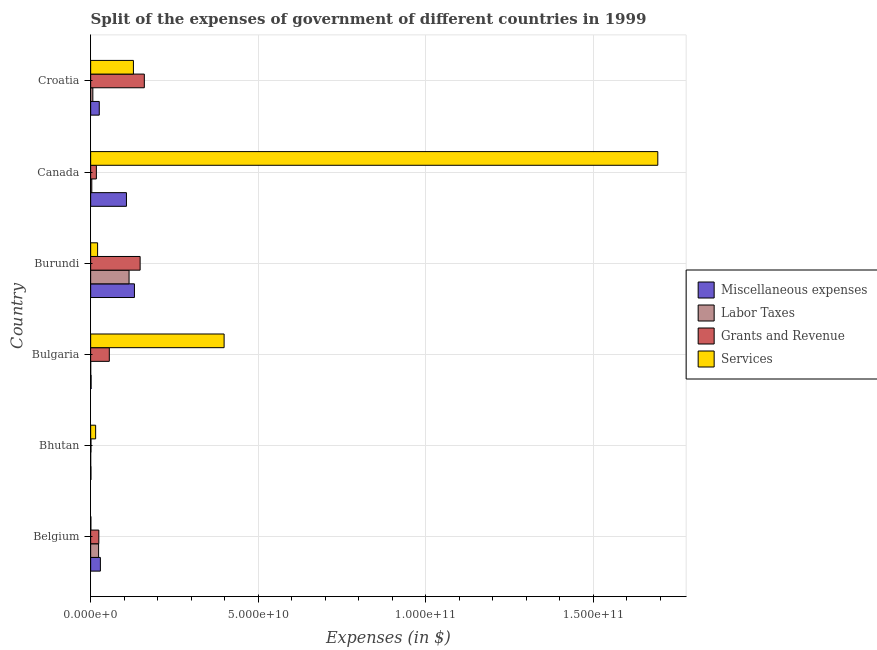How many different coloured bars are there?
Keep it short and to the point. 4. How many groups of bars are there?
Keep it short and to the point. 6. Are the number of bars on each tick of the Y-axis equal?
Offer a terse response. Yes. How many bars are there on the 5th tick from the top?
Your answer should be very brief. 4. What is the label of the 3rd group of bars from the top?
Keep it short and to the point. Burundi. What is the amount spent on services in Burundi?
Your answer should be compact. 2.07e+09. Across all countries, what is the maximum amount spent on services?
Your answer should be very brief. 1.69e+11. Across all countries, what is the minimum amount spent on grants and revenue?
Provide a succinct answer. 9.57e+07. In which country was the amount spent on grants and revenue minimum?
Offer a very short reply. Bhutan. What is the total amount spent on miscellaneous expenses in the graph?
Offer a very short reply. 2.94e+1. What is the difference between the amount spent on grants and revenue in Burundi and that in Canada?
Provide a succinct answer. 1.31e+1. What is the difference between the amount spent on labor taxes in Bulgaria and the amount spent on services in Belgium?
Ensure brevity in your answer.  -5.53e+07. What is the average amount spent on labor taxes per country?
Offer a terse response. 2.47e+09. What is the difference between the amount spent on grants and revenue and amount spent on services in Bulgaria?
Your answer should be compact. -3.42e+1. What is the ratio of the amount spent on services in Bulgaria to that in Canada?
Make the answer very short. 0.23. Is the difference between the amount spent on labor taxes in Bhutan and Canada greater than the difference between the amount spent on grants and revenue in Bhutan and Canada?
Your answer should be compact. Yes. What is the difference between the highest and the second highest amount spent on grants and revenue?
Your answer should be very brief. 1.25e+09. What is the difference between the highest and the lowest amount spent on services?
Offer a very short reply. 1.69e+11. What does the 1st bar from the top in Bulgaria represents?
Provide a succinct answer. Services. What does the 1st bar from the bottom in Bhutan represents?
Your answer should be compact. Miscellaneous expenses. How many bars are there?
Your answer should be compact. 24. What is the difference between two consecutive major ticks on the X-axis?
Your response must be concise. 5.00e+1. Are the values on the major ticks of X-axis written in scientific E-notation?
Ensure brevity in your answer.  Yes. Does the graph contain grids?
Keep it short and to the point. Yes. Where does the legend appear in the graph?
Provide a succinct answer. Center right. How are the legend labels stacked?
Provide a succinct answer. Vertical. What is the title of the graph?
Your answer should be very brief. Split of the expenses of government of different countries in 1999. What is the label or title of the X-axis?
Provide a succinct answer. Expenses (in $). What is the Expenses (in $) of Miscellaneous expenses in Belgium?
Give a very brief answer. 2.90e+09. What is the Expenses (in $) of Labor Taxes in Belgium?
Your answer should be very brief. 2.37e+09. What is the Expenses (in $) of Grants and Revenue in Belgium?
Keep it short and to the point. 2.44e+09. What is the Expenses (in $) of Services in Belgium?
Give a very brief answer. 6.24e+07. What is the Expenses (in $) in Miscellaneous expenses in Bhutan?
Keep it short and to the point. 8.63e+07. What is the Expenses (in $) in Labor Taxes in Bhutan?
Offer a terse response. 2.14e+06. What is the Expenses (in $) in Grants and Revenue in Bhutan?
Provide a succinct answer. 9.57e+07. What is the Expenses (in $) in Services in Bhutan?
Offer a very short reply. 1.49e+09. What is the Expenses (in $) of Miscellaneous expenses in Bulgaria?
Your answer should be compact. 1.36e+08. What is the Expenses (in $) of Labor Taxes in Bulgaria?
Give a very brief answer. 7.10e+06. What is the Expenses (in $) in Grants and Revenue in Bulgaria?
Offer a terse response. 5.57e+09. What is the Expenses (in $) in Services in Bulgaria?
Your answer should be compact. 3.98e+1. What is the Expenses (in $) of Miscellaneous expenses in Burundi?
Make the answer very short. 1.31e+1. What is the Expenses (in $) of Labor Taxes in Burundi?
Keep it short and to the point. 1.15e+1. What is the Expenses (in $) of Grants and Revenue in Burundi?
Offer a very short reply. 1.48e+1. What is the Expenses (in $) of Services in Burundi?
Keep it short and to the point. 2.07e+09. What is the Expenses (in $) in Miscellaneous expenses in Canada?
Your answer should be very brief. 1.07e+1. What is the Expenses (in $) in Labor Taxes in Canada?
Give a very brief answer. 3.39e+08. What is the Expenses (in $) of Grants and Revenue in Canada?
Keep it short and to the point. 1.70e+09. What is the Expenses (in $) of Services in Canada?
Offer a very short reply. 1.69e+11. What is the Expenses (in $) in Miscellaneous expenses in Croatia?
Offer a very short reply. 2.57e+09. What is the Expenses (in $) of Labor Taxes in Croatia?
Your answer should be compact. 6.53e+08. What is the Expenses (in $) in Grants and Revenue in Croatia?
Provide a succinct answer. 1.60e+1. What is the Expenses (in $) of Services in Croatia?
Your response must be concise. 1.28e+1. Across all countries, what is the maximum Expenses (in $) of Miscellaneous expenses?
Offer a terse response. 1.31e+1. Across all countries, what is the maximum Expenses (in $) of Labor Taxes?
Make the answer very short. 1.15e+1. Across all countries, what is the maximum Expenses (in $) of Grants and Revenue?
Provide a short and direct response. 1.60e+1. Across all countries, what is the maximum Expenses (in $) of Services?
Give a very brief answer. 1.69e+11. Across all countries, what is the minimum Expenses (in $) of Miscellaneous expenses?
Ensure brevity in your answer.  8.63e+07. Across all countries, what is the minimum Expenses (in $) of Labor Taxes?
Give a very brief answer. 2.14e+06. Across all countries, what is the minimum Expenses (in $) of Grants and Revenue?
Give a very brief answer. 9.57e+07. Across all countries, what is the minimum Expenses (in $) of Services?
Ensure brevity in your answer.  6.24e+07. What is the total Expenses (in $) in Miscellaneous expenses in the graph?
Give a very brief answer. 2.94e+1. What is the total Expenses (in $) in Labor Taxes in the graph?
Provide a short and direct response. 1.48e+1. What is the total Expenses (in $) of Grants and Revenue in the graph?
Keep it short and to the point. 4.06e+1. What is the total Expenses (in $) in Services in the graph?
Your response must be concise. 2.25e+11. What is the difference between the Expenses (in $) of Miscellaneous expenses in Belgium and that in Bhutan?
Give a very brief answer. 2.82e+09. What is the difference between the Expenses (in $) of Labor Taxes in Belgium and that in Bhutan?
Your response must be concise. 2.37e+09. What is the difference between the Expenses (in $) in Grants and Revenue in Belgium and that in Bhutan?
Provide a short and direct response. 2.34e+09. What is the difference between the Expenses (in $) in Services in Belgium and that in Bhutan?
Offer a terse response. -1.42e+09. What is the difference between the Expenses (in $) in Miscellaneous expenses in Belgium and that in Bulgaria?
Give a very brief answer. 2.77e+09. What is the difference between the Expenses (in $) of Labor Taxes in Belgium and that in Bulgaria?
Ensure brevity in your answer.  2.37e+09. What is the difference between the Expenses (in $) of Grants and Revenue in Belgium and that in Bulgaria?
Your answer should be very brief. -3.13e+09. What is the difference between the Expenses (in $) of Services in Belgium and that in Bulgaria?
Keep it short and to the point. -3.98e+1. What is the difference between the Expenses (in $) of Miscellaneous expenses in Belgium and that in Burundi?
Your response must be concise. -1.02e+1. What is the difference between the Expenses (in $) of Labor Taxes in Belgium and that in Burundi?
Provide a succinct answer. -9.09e+09. What is the difference between the Expenses (in $) in Grants and Revenue in Belgium and that in Burundi?
Keep it short and to the point. -1.23e+1. What is the difference between the Expenses (in $) in Services in Belgium and that in Burundi?
Your answer should be compact. -2.01e+09. What is the difference between the Expenses (in $) in Miscellaneous expenses in Belgium and that in Canada?
Provide a short and direct response. -7.78e+09. What is the difference between the Expenses (in $) of Labor Taxes in Belgium and that in Canada?
Keep it short and to the point. 2.03e+09. What is the difference between the Expenses (in $) in Grants and Revenue in Belgium and that in Canada?
Provide a short and direct response. 7.36e+08. What is the difference between the Expenses (in $) in Services in Belgium and that in Canada?
Keep it short and to the point. -1.69e+11. What is the difference between the Expenses (in $) of Miscellaneous expenses in Belgium and that in Croatia?
Offer a very short reply. 3.37e+08. What is the difference between the Expenses (in $) of Labor Taxes in Belgium and that in Croatia?
Provide a short and direct response. 1.72e+09. What is the difference between the Expenses (in $) in Grants and Revenue in Belgium and that in Croatia?
Your answer should be compact. -1.36e+1. What is the difference between the Expenses (in $) in Services in Belgium and that in Croatia?
Your answer should be compact. -1.27e+1. What is the difference between the Expenses (in $) in Miscellaneous expenses in Bhutan and that in Bulgaria?
Offer a terse response. -5.00e+07. What is the difference between the Expenses (in $) of Labor Taxes in Bhutan and that in Bulgaria?
Provide a succinct answer. -4.96e+06. What is the difference between the Expenses (in $) of Grants and Revenue in Bhutan and that in Bulgaria?
Provide a succinct answer. -5.47e+09. What is the difference between the Expenses (in $) in Services in Bhutan and that in Bulgaria?
Give a very brief answer. -3.83e+1. What is the difference between the Expenses (in $) in Miscellaneous expenses in Bhutan and that in Burundi?
Give a very brief answer. -1.30e+1. What is the difference between the Expenses (in $) in Labor Taxes in Bhutan and that in Burundi?
Ensure brevity in your answer.  -1.15e+1. What is the difference between the Expenses (in $) in Grants and Revenue in Bhutan and that in Burundi?
Ensure brevity in your answer.  -1.47e+1. What is the difference between the Expenses (in $) of Services in Bhutan and that in Burundi?
Your answer should be very brief. -5.82e+08. What is the difference between the Expenses (in $) in Miscellaneous expenses in Bhutan and that in Canada?
Make the answer very short. -1.06e+1. What is the difference between the Expenses (in $) of Labor Taxes in Bhutan and that in Canada?
Offer a very short reply. -3.37e+08. What is the difference between the Expenses (in $) in Grants and Revenue in Bhutan and that in Canada?
Your answer should be very brief. -1.61e+09. What is the difference between the Expenses (in $) in Services in Bhutan and that in Canada?
Ensure brevity in your answer.  -1.68e+11. What is the difference between the Expenses (in $) of Miscellaneous expenses in Bhutan and that in Croatia?
Provide a short and direct response. -2.48e+09. What is the difference between the Expenses (in $) in Labor Taxes in Bhutan and that in Croatia?
Give a very brief answer. -6.51e+08. What is the difference between the Expenses (in $) of Grants and Revenue in Bhutan and that in Croatia?
Your answer should be very brief. -1.59e+1. What is the difference between the Expenses (in $) in Services in Bhutan and that in Croatia?
Your answer should be compact. -1.13e+1. What is the difference between the Expenses (in $) of Miscellaneous expenses in Bulgaria and that in Burundi?
Offer a very short reply. -1.29e+1. What is the difference between the Expenses (in $) of Labor Taxes in Bulgaria and that in Burundi?
Your response must be concise. -1.15e+1. What is the difference between the Expenses (in $) in Grants and Revenue in Bulgaria and that in Burundi?
Provide a succinct answer. -9.19e+09. What is the difference between the Expenses (in $) in Services in Bulgaria and that in Burundi?
Ensure brevity in your answer.  3.77e+1. What is the difference between the Expenses (in $) of Miscellaneous expenses in Bulgaria and that in Canada?
Offer a terse response. -1.05e+1. What is the difference between the Expenses (in $) of Labor Taxes in Bulgaria and that in Canada?
Your response must be concise. -3.32e+08. What is the difference between the Expenses (in $) in Grants and Revenue in Bulgaria and that in Canada?
Offer a terse response. 3.86e+09. What is the difference between the Expenses (in $) in Services in Bulgaria and that in Canada?
Your answer should be compact. -1.29e+11. What is the difference between the Expenses (in $) of Miscellaneous expenses in Bulgaria and that in Croatia?
Your answer should be very brief. -2.43e+09. What is the difference between the Expenses (in $) of Labor Taxes in Bulgaria and that in Croatia?
Your answer should be very brief. -6.46e+08. What is the difference between the Expenses (in $) of Grants and Revenue in Bulgaria and that in Croatia?
Ensure brevity in your answer.  -1.04e+1. What is the difference between the Expenses (in $) of Services in Bulgaria and that in Croatia?
Offer a very short reply. 2.71e+1. What is the difference between the Expenses (in $) in Miscellaneous expenses in Burundi and that in Canada?
Your response must be concise. 2.38e+09. What is the difference between the Expenses (in $) in Labor Taxes in Burundi and that in Canada?
Make the answer very short. 1.11e+1. What is the difference between the Expenses (in $) in Grants and Revenue in Burundi and that in Canada?
Keep it short and to the point. 1.31e+1. What is the difference between the Expenses (in $) of Services in Burundi and that in Canada?
Make the answer very short. -1.67e+11. What is the difference between the Expenses (in $) of Miscellaneous expenses in Burundi and that in Croatia?
Ensure brevity in your answer.  1.05e+1. What is the difference between the Expenses (in $) of Labor Taxes in Burundi and that in Croatia?
Your response must be concise. 1.08e+1. What is the difference between the Expenses (in $) of Grants and Revenue in Burundi and that in Croatia?
Your answer should be compact. -1.25e+09. What is the difference between the Expenses (in $) of Services in Burundi and that in Croatia?
Provide a succinct answer. -1.07e+1. What is the difference between the Expenses (in $) of Miscellaneous expenses in Canada and that in Croatia?
Keep it short and to the point. 8.11e+09. What is the difference between the Expenses (in $) in Labor Taxes in Canada and that in Croatia?
Your answer should be compact. -3.14e+08. What is the difference between the Expenses (in $) of Grants and Revenue in Canada and that in Croatia?
Provide a short and direct response. -1.43e+1. What is the difference between the Expenses (in $) of Services in Canada and that in Croatia?
Offer a terse response. 1.56e+11. What is the difference between the Expenses (in $) in Miscellaneous expenses in Belgium and the Expenses (in $) in Labor Taxes in Bhutan?
Offer a very short reply. 2.90e+09. What is the difference between the Expenses (in $) of Miscellaneous expenses in Belgium and the Expenses (in $) of Grants and Revenue in Bhutan?
Ensure brevity in your answer.  2.81e+09. What is the difference between the Expenses (in $) of Miscellaneous expenses in Belgium and the Expenses (in $) of Services in Bhutan?
Keep it short and to the point. 1.42e+09. What is the difference between the Expenses (in $) of Labor Taxes in Belgium and the Expenses (in $) of Grants and Revenue in Bhutan?
Provide a short and direct response. 2.28e+09. What is the difference between the Expenses (in $) in Labor Taxes in Belgium and the Expenses (in $) in Services in Bhutan?
Make the answer very short. 8.86e+08. What is the difference between the Expenses (in $) in Grants and Revenue in Belgium and the Expenses (in $) in Services in Bhutan?
Keep it short and to the point. 9.54e+08. What is the difference between the Expenses (in $) in Miscellaneous expenses in Belgium and the Expenses (in $) in Labor Taxes in Bulgaria?
Provide a succinct answer. 2.90e+09. What is the difference between the Expenses (in $) of Miscellaneous expenses in Belgium and the Expenses (in $) of Grants and Revenue in Bulgaria?
Make the answer very short. -2.66e+09. What is the difference between the Expenses (in $) of Miscellaneous expenses in Belgium and the Expenses (in $) of Services in Bulgaria?
Give a very brief answer. -3.69e+1. What is the difference between the Expenses (in $) in Labor Taxes in Belgium and the Expenses (in $) in Grants and Revenue in Bulgaria?
Your answer should be compact. -3.19e+09. What is the difference between the Expenses (in $) in Labor Taxes in Belgium and the Expenses (in $) in Services in Bulgaria?
Give a very brief answer. -3.74e+1. What is the difference between the Expenses (in $) in Grants and Revenue in Belgium and the Expenses (in $) in Services in Bulgaria?
Your answer should be very brief. -3.74e+1. What is the difference between the Expenses (in $) of Miscellaneous expenses in Belgium and the Expenses (in $) of Labor Taxes in Burundi?
Ensure brevity in your answer.  -8.55e+09. What is the difference between the Expenses (in $) of Miscellaneous expenses in Belgium and the Expenses (in $) of Grants and Revenue in Burundi?
Provide a short and direct response. -1.19e+1. What is the difference between the Expenses (in $) of Miscellaneous expenses in Belgium and the Expenses (in $) of Services in Burundi?
Ensure brevity in your answer.  8.36e+08. What is the difference between the Expenses (in $) in Labor Taxes in Belgium and the Expenses (in $) in Grants and Revenue in Burundi?
Make the answer very short. -1.24e+1. What is the difference between the Expenses (in $) of Labor Taxes in Belgium and the Expenses (in $) of Services in Burundi?
Your answer should be compact. 3.05e+08. What is the difference between the Expenses (in $) of Grants and Revenue in Belgium and the Expenses (in $) of Services in Burundi?
Offer a terse response. 3.72e+08. What is the difference between the Expenses (in $) of Miscellaneous expenses in Belgium and the Expenses (in $) of Labor Taxes in Canada?
Give a very brief answer. 2.56e+09. What is the difference between the Expenses (in $) of Miscellaneous expenses in Belgium and the Expenses (in $) of Grants and Revenue in Canada?
Provide a short and direct response. 1.20e+09. What is the difference between the Expenses (in $) of Miscellaneous expenses in Belgium and the Expenses (in $) of Services in Canada?
Ensure brevity in your answer.  -1.66e+11. What is the difference between the Expenses (in $) of Labor Taxes in Belgium and the Expenses (in $) of Grants and Revenue in Canada?
Keep it short and to the point. 6.69e+08. What is the difference between the Expenses (in $) of Labor Taxes in Belgium and the Expenses (in $) of Services in Canada?
Offer a terse response. -1.67e+11. What is the difference between the Expenses (in $) of Grants and Revenue in Belgium and the Expenses (in $) of Services in Canada?
Offer a very short reply. -1.67e+11. What is the difference between the Expenses (in $) of Miscellaneous expenses in Belgium and the Expenses (in $) of Labor Taxes in Croatia?
Keep it short and to the point. 2.25e+09. What is the difference between the Expenses (in $) in Miscellaneous expenses in Belgium and the Expenses (in $) in Grants and Revenue in Croatia?
Your response must be concise. -1.31e+1. What is the difference between the Expenses (in $) in Miscellaneous expenses in Belgium and the Expenses (in $) in Services in Croatia?
Your answer should be very brief. -9.85e+09. What is the difference between the Expenses (in $) in Labor Taxes in Belgium and the Expenses (in $) in Grants and Revenue in Croatia?
Provide a short and direct response. -1.36e+1. What is the difference between the Expenses (in $) of Labor Taxes in Belgium and the Expenses (in $) of Services in Croatia?
Make the answer very short. -1.04e+1. What is the difference between the Expenses (in $) in Grants and Revenue in Belgium and the Expenses (in $) in Services in Croatia?
Give a very brief answer. -1.03e+1. What is the difference between the Expenses (in $) of Miscellaneous expenses in Bhutan and the Expenses (in $) of Labor Taxes in Bulgaria?
Keep it short and to the point. 7.92e+07. What is the difference between the Expenses (in $) in Miscellaneous expenses in Bhutan and the Expenses (in $) in Grants and Revenue in Bulgaria?
Provide a short and direct response. -5.48e+09. What is the difference between the Expenses (in $) of Miscellaneous expenses in Bhutan and the Expenses (in $) of Services in Bulgaria?
Ensure brevity in your answer.  -3.97e+1. What is the difference between the Expenses (in $) in Labor Taxes in Bhutan and the Expenses (in $) in Grants and Revenue in Bulgaria?
Keep it short and to the point. -5.57e+09. What is the difference between the Expenses (in $) of Labor Taxes in Bhutan and the Expenses (in $) of Services in Bulgaria?
Provide a short and direct response. -3.98e+1. What is the difference between the Expenses (in $) of Grants and Revenue in Bhutan and the Expenses (in $) of Services in Bulgaria?
Offer a terse response. -3.97e+1. What is the difference between the Expenses (in $) of Miscellaneous expenses in Bhutan and the Expenses (in $) of Labor Taxes in Burundi?
Offer a very short reply. -1.14e+1. What is the difference between the Expenses (in $) in Miscellaneous expenses in Bhutan and the Expenses (in $) in Grants and Revenue in Burundi?
Provide a succinct answer. -1.47e+1. What is the difference between the Expenses (in $) in Miscellaneous expenses in Bhutan and the Expenses (in $) in Services in Burundi?
Provide a succinct answer. -1.98e+09. What is the difference between the Expenses (in $) of Labor Taxes in Bhutan and the Expenses (in $) of Grants and Revenue in Burundi?
Your response must be concise. -1.48e+1. What is the difference between the Expenses (in $) in Labor Taxes in Bhutan and the Expenses (in $) in Services in Burundi?
Your response must be concise. -2.07e+09. What is the difference between the Expenses (in $) of Grants and Revenue in Bhutan and the Expenses (in $) of Services in Burundi?
Your response must be concise. -1.97e+09. What is the difference between the Expenses (in $) in Miscellaneous expenses in Bhutan and the Expenses (in $) in Labor Taxes in Canada?
Provide a short and direct response. -2.53e+08. What is the difference between the Expenses (in $) in Miscellaneous expenses in Bhutan and the Expenses (in $) in Grants and Revenue in Canada?
Your answer should be compact. -1.62e+09. What is the difference between the Expenses (in $) of Miscellaneous expenses in Bhutan and the Expenses (in $) of Services in Canada?
Offer a very short reply. -1.69e+11. What is the difference between the Expenses (in $) in Labor Taxes in Bhutan and the Expenses (in $) in Grants and Revenue in Canada?
Offer a very short reply. -1.70e+09. What is the difference between the Expenses (in $) in Labor Taxes in Bhutan and the Expenses (in $) in Services in Canada?
Offer a terse response. -1.69e+11. What is the difference between the Expenses (in $) in Grants and Revenue in Bhutan and the Expenses (in $) in Services in Canada?
Provide a succinct answer. -1.69e+11. What is the difference between the Expenses (in $) of Miscellaneous expenses in Bhutan and the Expenses (in $) of Labor Taxes in Croatia?
Provide a short and direct response. -5.67e+08. What is the difference between the Expenses (in $) of Miscellaneous expenses in Bhutan and the Expenses (in $) of Grants and Revenue in Croatia?
Keep it short and to the point. -1.59e+1. What is the difference between the Expenses (in $) of Miscellaneous expenses in Bhutan and the Expenses (in $) of Services in Croatia?
Keep it short and to the point. -1.27e+1. What is the difference between the Expenses (in $) of Labor Taxes in Bhutan and the Expenses (in $) of Grants and Revenue in Croatia?
Your answer should be very brief. -1.60e+1. What is the difference between the Expenses (in $) of Labor Taxes in Bhutan and the Expenses (in $) of Services in Croatia?
Offer a terse response. -1.28e+1. What is the difference between the Expenses (in $) in Grants and Revenue in Bhutan and the Expenses (in $) in Services in Croatia?
Provide a succinct answer. -1.27e+1. What is the difference between the Expenses (in $) in Miscellaneous expenses in Bulgaria and the Expenses (in $) in Labor Taxes in Burundi?
Provide a succinct answer. -1.13e+1. What is the difference between the Expenses (in $) in Miscellaneous expenses in Bulgaria and the Expenses (in $) in Grants and Revenue in Burundi?
Provide a short and direct response. -1.46e+1. What is the difference between the Expenses (in $) of Miscellaneous expenses in Bulgaria and the Expenses (in $) of Services in Burundi?
Your response must be concise. -1.93e+09. What is the difference between the Expenses (in $) in Labor Taxes in Bulgaria and the Expenses (in $) in Grants and Revenue in Burundi?
Provide a succinct answer. -1.48e+1. What is the difference between the Expenses (in $) of Labor Taxes in Bulgaria and the Expenses (in $) of Services in Burundi?
Make the answer very short. -2.06e+09. What is the difference between the Expenses (in $) in Grants and Revenue in Bulgaria and the Expenses (in $) in Services in Burundi?
Offer a very short reply. 3.50e+09. What is the difference between the Expenses (in $) of Miscellaneous expenses in Bulgaria and the Expenses (in $) of Labor Taxes in Canada?
Give a very brief answer. -2.03e+08. What is the difference between the Expenses (in $) in Miscellaneous expenses in Bulgaria and the Expenses (in $) in Grants and Revenue in Canada?
Make the answer very short. -1.57e+09. What is the difference between the Expenses (in $) of Miscellaneous expenses in Bulgaria and the Expenses (in $) of Services in Canada?
Provide a succinct answer. -1.69e+11. What is the difference between the Expenses (in $) of Labor Taxes in Bulgaria and the Expenses (in $) of Grants and Revenue in Canada?
Give a very brief answer. -1.70e+09. What is the difference between the Expenses (in $) in Labor Taxes in Bulgaria and the Expenses (in $) in Services in Canada?
Give a very brief answer. -1.69e+11. What is the difference between the Expenses (in $) of Grants and Revenue in Bulgaria and the Expenses (in $) of Services in Canada?
Give a very brief answer. -1.64e+11. What is the difference between the Expenses (in $) of Miscellaneous expenses in Bulgaria and the Expenses (in $) of Labor Taxes in Croatia?
Offer a terse response. -5.17e+08. What is the difference between the Expenses (in $) in Miscellaneous expenses in Bulgaria and the Expenses (in $) in Grants and Revenue in Croatia?
Provide a succinct answer. -1.59e+1. What is the difference between the Expenses (in $) in Miscellaneous expenses in Bulgaria and the Expenses (in $) in Services in Croatia?
Give a very brief answer. -1.26e+1. What is the difference between the Expenses (in $) of Labor Taxes in Bulgaria and the Expenses (in $) of Grants and Revenue in Croatia?
Make the answer very short. -1.60e+1. What is the difference between the Expenses (in $) in Labor Taxes in Bulgaria and the Expenses (in $) in Services in Croatia?
Your answer should be compact. -1.27e+1. What is the difference between the Expenses (in $) in Grants and Revenue in Bulgaria and the Expenses (in $) in Services in Croatia?
Make the answer very short. -7.19e+09. What is the difference between the Expenses (in $) in Miscellaneous expenses in Burundi and the Expenses (in $) in Labor Taxes in Canada?
Your answer should be very brief. 1.27e+1. What is the difference between the Expenses (in $) in Miscellaneous expenses in Burundi and the Expenses (in $) in Grants and Revenue in Canada?
Keep it short and to the point. 1.14e+1. What is the difference between the Expenses (in $) in Miscellaneous expenses in Burundi and the Expenses (in $) in Services in Canada?
Your answer should be compact. -1.56e+11. What is the difference between the Expenses (in $) of Labor Taxes in Burundi and the Expenses (in $) of Grants and Revenue in Canada?
Make the answer very short. 9.75e+09. What is the difference between the Expenses (in $) in Labor Taxes in Burundi and the Expenses (in $) in Services in Canada?
Provide a short and direct response. -1.58e+11. What is the difference between the Expenses (in $) of Grants and Revenue in Burundi and the Expenses (in $) of Services in Canada?
Ensure brevity in your answer.  -1.54e+11. What is the difference between the Expenses (in $) in Miscellaneous expenses in Burundi and the Expenses (in $) in Labor Taxes in Croatia?
Give a very brief answer. 1.24e+1. What is the difference between the Expenses (in $) of Miscellaneous expenses in Burundi and the Expenses (in $) of Grants and Revenue in Croatia?
Make the answer very short. -2.95e+09. What is the difference between the Expenses (in $) in Miscellaneous expenses in Burundi and the Expenses (in $) in Services in Croatia?
Offer a terse response. 3.07e+08. What is the difference between the Expenses (in $) in Labor Taxes in Burundi and the Expenses (in $) in Grants and Revenue in Croatia?
Ensure brevity in your answer.  -4.55e+09. What is the difference between the Expenses (in $) of Labor Taxes in Burundi and the Expenses (in $) of Services in Croatia?
Keep it short and to the point. -1.30e+09. What is the difference between the Expenses (in $) of Grants and Revenue in Burundi and the Expenses (in $) of Services in Croatia?
Make the answer very short. 2.00e+09. What is the difference between the Expenses (in $) of Miscellaneous expenses in Canada and the Expenses (in $) of Labor Taxes in Croatia?
Offer a very short reply. 1.00e+1. What is the difference between the Expenses (in $) in Miscellaneous expenses in Canada and the Expenses (in $) in Grants and Revenue in Croatia?
Keep it short and to the point. -5.33e+09. What is the difference between the Expenses (in $) of Miscellaneous expenses in Canada and the Expenses (in $) of Services in Croatia?
Give a very brief answer. -2.08e+09. What is the difference between the Expenses (in $) in Labor Taxes in Canada and the Expenses (in $) in Grants and Revenue in Croatia?
Offer a very short reply. -1.57e+1. What is the difference between the Expenses (in $) of Labor Taxes in Canada and the Expenses (in $) of Services in Croatia?
Your answer should be very brief. -1.24e+1. What is the difference between the Expenses (in $) in Grants and Revenue in Canada and the Expenses (in $) in Services in Croatia?
Your response must be concise. -1.11e+1. What is the average Expenses (in $) in Miscellaneous expenses per country?
Your answer should be compact. 4.91e+09. What is the average Expenses (in $) in Labor Taxes per country?
Make the answer very short. 2.47e+09. What is the average Expenses (in $) of Grants and Revenue per country?
Keep it short and to the point. 6.76e+09. What is the average Expenses (in $) of Services per country?
Your response must be concise. 3.76e+1. What is the difference between the Expenses (in $) of Miscellaneous expenses and Expenses (in $) of Labor Taxes in Belgium?
Keep it short and to the point. 5.31e+08. What is the difference between the Expenses (in $) in Miscellaneous expenses and Expenses (in $) in Grants and Revenue in Belgium?
Offer a very short reply. 4.64e+08. What is the difference between the Expenses (in $) in Miscellaneous expenses and Expenses (in $) in Services in Belgium?
Give a very brief answer. 2.84e+09. What is the difference between the Expenses (in $) of Labor Taxes and Expenses (in $) of Grants and Revenue in Belgium?
Keep it short and to the point. -6.70e+07. What is the difference between the Expenses (in $) of Labor Taxes and Expenses (in $) of Services in Belgium?
Make the answer very short. 2.31e+09. What is the difference between the Expenses (in $) of Grants and Revenue and Expenses (in $) of Services in Belgium?
Your response must be concise. 2.38e+09. What is the difference between the Expenses (in $) of Miscellaneous expenses and Expenses (in $) of Labor Taxes in Bhutan?
Your response must be concise. 8.42e+07. What is the difference between the Expenses (in $) of Miscellaneous expenses and Expenses (in $) of Grants and Revenue in Bhutan?
Your response must be concise. -9.38e+06. What is the difference between the Expenses (in $) in Miscellaneous expenses and Expenses (in $) in Services in Bhutan?
Provide a succinct answer. -1.40e+09. What is the difference between the Expenses (in $) in Labor Taxes and Expenses (in $) in Grants and Revenue in Bhutan?
Provide a succinct answer. -9.35e+07. What is the difference between the Expenses (in $) in Labor Taxes and Expenses (in $) in Services in Bhutan?
Offer a very short reply. -1.48e+09. What is the difference between the Expenses (in $) in Grants and Revenue and Expenses (in $) in Services in Bhutan?
Ensure brevity in your answer.  -1.39e+09. What is the difference between the Expenses (in $) in Miscellaneous expenses and Expenses (in $) in Labor Taxes in Bulgaria?
Ensure brevity in your answer.  1.29e+08. What is the difference between the Expenses (in $) of Miscellaneous expenses and Expenses (in $) of Grants and Revenue in Bulgaria?
Offer a very short reply. -5.43e+09. What is the difference between the Expenses (in $) in Miscellaneous expenses and Expenses (in $) in Services in Bulgaria?
Provide a succinct answer. -3.97e+1. What is the difference between the Expenses (in $) of Labor Taxes and Expenses (in $) of Grants and Revenue in Bulgaria?
Your answer should be compact. -5.56e+09. What is the difference between the Expenses (in $) in Labor Taxes and Expenses (in $) in Services in Bulgaria?
Your response must be concise. -3.98e+1. What is the difference between the Expenses (in $) of Grants and Revenue and Expenses (in $) of Services in Bulgaria?
Offer a very short reply. -3.42e+1. What is the difference between the Expenses (in $) of Miscellaneous expenses and Expenses (in $) of Labor Taxes in Burundi?
Your answer should be compact. 1.60e+09. What is the difference between the Expenses (in $) in Miscellaneous expenses and Expenses (in $) in Grants and Revenue in Burundi?
Provide a succinct answer. -1.70e+09. What is the difference between the Expenses (in $) of Miscellaneous expenses and Expenses (in $) of Services in Burundi?
Give a very brief answer. 1.10e+1. What is the difference between the Expenses (in $) of Labor Taxes and Expenses (in $) of Grants and Revenue in Burundi?
Offer a terse response. -3.30e+09. What is the difference between the Expenses (in $) in Labor Taxes and Expenses (in $) in Services in Burundi?
Your answer should be compact. 9.39e+09. What is the difference between the Expenses (in $) of Grants and Revenue and Expenses (in $) of Services in Burundi?
Your answer should be compact. 1.27e+1. What is the difference between the Expenses (in $) in Miscellaneous expenses and Expenses (in $) in Labor Taxes in Canada?
Make the answer very short. 1.03e+1. What is the difference between the Expenses (in $) in Miscellaneous expenses and Expenses (in $) in Grants and Revenue in Canada?
Provide a succinct answer. 8.98e+09. What is the difference between the Expenses (in $) in Miscellaneous expenses and Expenses (in $) in Services in Canada?
Your answer should be very brief. -1.59e+11. What is the difference between the Expenses (in $) in Labor Taxes and Expenses (in $) in Grants and Revenue in Canada?
Provide a succinct answer. -1.36e+09. What is the difference between the Expenses (in $) of Labor Taxes and Expenses (in $) of Services in Canada?
Provide a succinct answer. -1.69e+11. What is the difference between the Expenses (in $) in Grants and Revenue and Expenses (in $) in Services in Canada?
Your response must be concise. -1.67e+11. What is the difference between the Expenses (in $) in Miscellaneous expenses and Expenses (in $) in Labor Taxes in Croatia?
Offer a very short reply. 1.91e+09. What is the difference between the Expenses (in $) of Miscellaneous expenses and Expenses (in $) of Grants and Revenue in Croatia?
Offer a terse response. -1.34e+1. What is the difference between the Expenses (in $) in Miscellaneous expenses and Expenses (in $) in Services in Croatia?
Keep it short and to the point. -1.02e+1. What is the difference between the Expenses (in $) of Labor Taxes and Expenses (in $) of Grants and Revenue in Croatia?
Provide a succinct answer. -1.54e+1. What is the difference between the Expenses (in $) of Labor Taxes and Expenses (in $) of Services in Croatia?
Ensure brevity in your answer.  -1.21e+1. What is the difference between the Expenses (in $) in Grants and Revenue and Expenses (in $) in Services in Croatia?
Provide a succinct answer. 3.26e+09. What is the ratio of the Expenses (in $) of Miscellaneous expenses in Belgium to that in Bhutan?
Ensure brevity in your answer.  33.64. What is the ratio of the Expenses (in $) in Labor Taxes in Belgium to that in Bhutan?
Your answer should be compact. 1109.21. What is the ratio of the Expenses (in $) in Grants and Revenue in Belgium to that in Bhutan?
Provide a short and direct response. 25.5. What is the ratio of the Expenses (in $) of Services in Belgium to that in Bhutan?
Your answer should be compact. 0.04. What is the ratio of the Expenses (in $) of Miscellaneous expenses in Belgium to that in Bulgaria?
Make the answer very short. 21.29. What is the ratio of the Expenses (in $) of Labor Taxes in Belgium to that in Bulgaria?
Provide a succinct answer. 334.17. What is the ratio of the Expenses (in $) of Grants and Revenue in Belgium to that in Bulgaria?
Keep it short and to the point. 0.44. What is the ratio of the Expenses (in $) in Services in Belgium to that in Bulgaria?
Your answer should be compact. 0. What is the ratio of the Expenses (in $) in Miscellaneous expenses in Belgium to that in Burundi?
Give a very brief answer. 0.22. What is the ratio of the Expenses (in $) in Labor Taxes in Belgium to that in Burundi?
Your answer should be very brief. 0.21. What is the ratio of the Expenses (in $) of Grants and Revenue in Belgium to that in Burundi?
Provide a succinct answer. 0.17. What is the ratio of the Expenses (in $) of Services in Belgium to that in Burundi?
Offer a very short reply. 0.03. What is the ratio of the Expenses (in $) in Miscellaneous expenses in Belgium to that in Canada?
Offer a terse response. 0.27. What is the ratio of the Expenses (in $) of Labor Taxes in Belgium to that in Canada?
Your answer should be compact. 6.99. What is the ratio of the Expenses (in $) of Grants and Revenue in Belgium to that in Canada?
Offer a very short reply. 1.43. What is the ratio of the Expenses (in $) of Miscellaneous expenses in Belgium to that in Croatia?
Provide a succinct answer. 1.13. What is the ratio of the Expenses (in $) in Labor Taxes in Belgium to that in Croatia?
Provide a succinct answer. 3.63. What is the ratio of the Expenses (in $) of Grants and Revenue in Belgium to that in Croatia?
Your answer should be very brief. 0.15. What is the ratio of the Expenses (in $) of Services in Belgium to that in Croatia?
Make the answer very short. 0. What is the ratio of the Expenses (in $) of Miscellaneous expenses in Bhutan to that in Bulgaria?
Your answer should be compact. 0.63. What is the ratio of the Expenses (in $) of Labor Taxes in Bhutan to that in Bulgaria?
Offer a terse response. 0.3. What is the ratio of the Expenses (in $) in Grants and Revenue in Bhutan to that in Bulgaria?
Provide a short and direct response. 0.02. What is the ratio of the Expenses (in $) of Services in Bhutan to that in Bulgaria?
Your answer should be compact. 0.04. What is the ratio of the Expenses (in $) in Miscellaneous expenses in Bhutan to that in Burundi?
Provide a short and direct response. 0.01. What is the ratio of the Expenses (in $) in Grants and Revenue in Bhutan to that in Burundi?
Keep it short and to the point. 0.01. What is the ratio of the Expenses (in $) in Services in Bhutan to that in Burundi?
Your answer should be very brief. 0.72. What is the ratio of the Expenses (in $) of Miscellaneous expenses in Bhutan to that in Canada?
Offer a terse response. 0.01. What is the ratio of the Expenses (in $) of Labor Taxes in Bhutan to that in Canada?
Offer a very short reply. 0.01. What is the ratio of the Expenses (in $) of Grants and Revenue in Bhutan to that in Canada?
Give a very brief answer. 0.06. What is the ratio of the Expenses (in $) in Services in Bhutan to that in Canada?
Make the answer very short. 0.01. What is the ratio of the Expenses (in $) in Miscellaneous expenses in Bhutan to that in Croatia?
Your answer should be very brief. 0.03. What is the ratio of the Expenses (in $) of Labor Taxes in Bhutan to that in Croatia?
Make the answer very short. 0. What is the ratio of the Expenses (in $) in Grants and Revenue in Bhutan to that in Croatia?
Provide a succinct answer. 0.01. What is the ratio of the Expenses (in $) of Services in Bhutan to that in Croatia?
Provide a succinct answer. 0.12. What is the ratio of the Expenses (in $) in Miscellaneous expenses in Bulgaria to that in Burundi?
Provide a short and direct response. 0.01. What is the ratio of the Expenses (in $) of Labor Taxes in Bulgaria to that in Burundi?
Give a very brief answer. 0. What is the ratio of the Expenses (in $) of Grants and Revenue in Bulgaria to that in Burundi?
Offer a very short reply. 0.38. What is the ratio of the Expenses (in $) in Services in Bulgaria to that in Burundi?
Your answer should be compact. 19.25. What is the ratio of the Expenses (in $) in Miscellaneous expenses in Bulgaria to that in Canada?
Provide a short and direct response. 0.01. What is the ratio of the Expenses (in $) in Labor Taxes in Bulgaria to that in Canada?
Your response must be concise. 0.02. What is the ratio of the Expenses (in $) of Grants and Revenue in Bulgaria to that in Canada?
Give a very brief answer. 3.27. What is the ratio of the Expenses (in $) of Services in Bulgaria to that in Canada?
Provide a short and direct response. 0.24. What is the ratio of the Expenses (in $) in Miscellaneous expenses in Bulgaria to that in Croatia?
Provide a succinct answer. 0.05. What is the ratio of the Expenses (in $) of Labor Taxes in Bulgaria to that in Croatia?
Offer a very short reply. 0.01. What is the ratio of the Expenses (in $) in Grants and Revenue in Bulgaria to that in Croatia?
Your answer should be very brief. 0.35. What is the ratio of the Expenses (in $) in Services in Bulgaria to that in Croatia?
Offer a terse response. 3.12. What is the ratio of the Expenses (in $) of Miscellaneous expenses in Burundi to that in Canada?
Offer a terse response. 1.22. What is the ratio of the Expenses (in $) of Labor Taxes in Burundi to that in Canada?
Make the answer very short. 33.78. What is the ratio of the Expenses (in $) of Grants and Revenue in Burundi to that in Canada?
Make the answer very short. 8.67. What is the ratio of the Expenses (in $) of Services in Burundi to that in Canada?
Your answer should be very brief. 0.01. What is the ratio of the Expenses (in $) in Miscellaneous expenses in Burundi to that in Croatia?
Offer a terse response. 5.09. What is the ratio of the Expenses (in $) of Labor Taxes in Burundi to that in Croatia?
Your response must be concise. 17.55. What is the ratio of the Expenses (in $) of Grants and Revenue in Burundi to that in Croatia?
Offer a very short reply. 0.92. What is the ratio of the Expenses (in $) of Services in Burundi to that in Croatia?
Offer a terse response. 0.16. What is the ratio of the Expenses (in $) in Miscellaneous expenses in Canada to that in Croatia?
Provide a succinct answer. 4.16. What is the ratio of the Expenses (in $) in Labor Taxes in Canada to that in Croatia?
Provide a succinct answer. 0.52. What is the ratio of the Expenses (in $) of Grants and Revenue in Canada to that in Croatia?
Your answer should be compact. 0.11. What is the ratio of the Expenses (in $) in Services in Canada to that in Croatia?
Offer a terse response. 13.26. What is the difference between the highest and the second highest Expenses (in $) in Miscellaneous expenses?
Ensure brevity in your answer.  2.38e+09. What is the difference between the highest and the second highest Expenses (in $) in Labor Taxes?
Your answer should be very brief. 9.09e+09. What is the difference between the highest and the second highest Expenses (in $) of Grants and Revenue?
Provide a succinct answer. 1.25e+09. What is the difference between the highest and the second highest Expenses (in $) of Services?
Your answer should be compact. 1.29e+11. What is the difference between the highest and the lowest Expenses (in $) in Miscellaneous expenses?
Keep it short and to the point. 1.30e+1. What is the difference between the highest and the lowest Expenses (in $) of Labor Taxes?
Make the answer very short. 1.15e+1. What is the difference between the highest and the lowest Expenses (in $) in Grants and Revenue?
Ensure brevity in your answer.  1.59e+1. What is the difference between the highest and the lowest Expenses (in $) of Services?
Keep it short and to the point. 1.69e+11. 